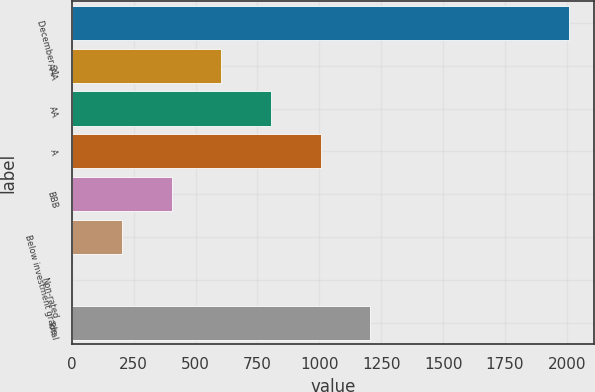Convert chart. <chart><loc_0><loc_0><loc_500><loc_500><bar_chart><fcel>December 31<fcel>AAA<fcel>AA<fcel>A<fcel>BBB<fcel>Below investment grade<fcel>Non-rated<fcel>Total<nl><fcel>2009<fcel>604.1<fcel>804.8<fcel>1005.5<fcel>403.4<fcel>202.7<fcel>2<fcel>1206.2<nl></chart> 